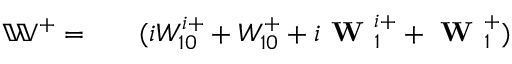Convert formula to latex. <formula><loc_0><loc_0><loc_500><loc_500>\begin{array} { r l r } { \mathbb { W } ^ { + } = } & { ( i W _ { 1 0 } ^ { i + } + W _ { 1 0 } ^ { + } + i W _ { 1 } ^ { i + } + W _ { 1 } ^ { + } ) } \end{array}</formula> 